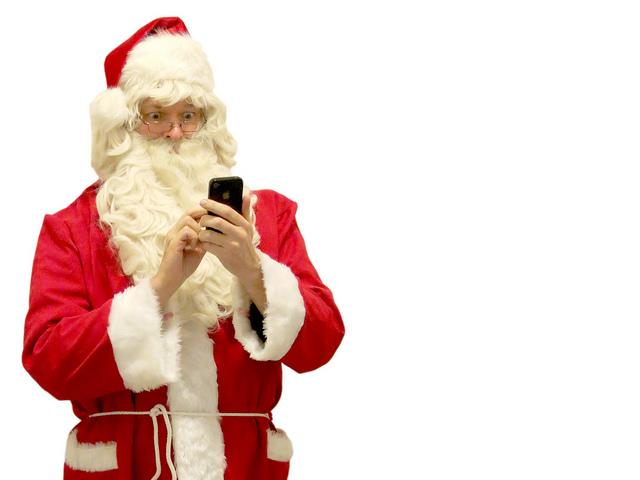Who is this?
Keep it brief. Santa. Could the person be texting?
Concise answer only. Yes. What season is it?
Quick response, please. Christmas. 